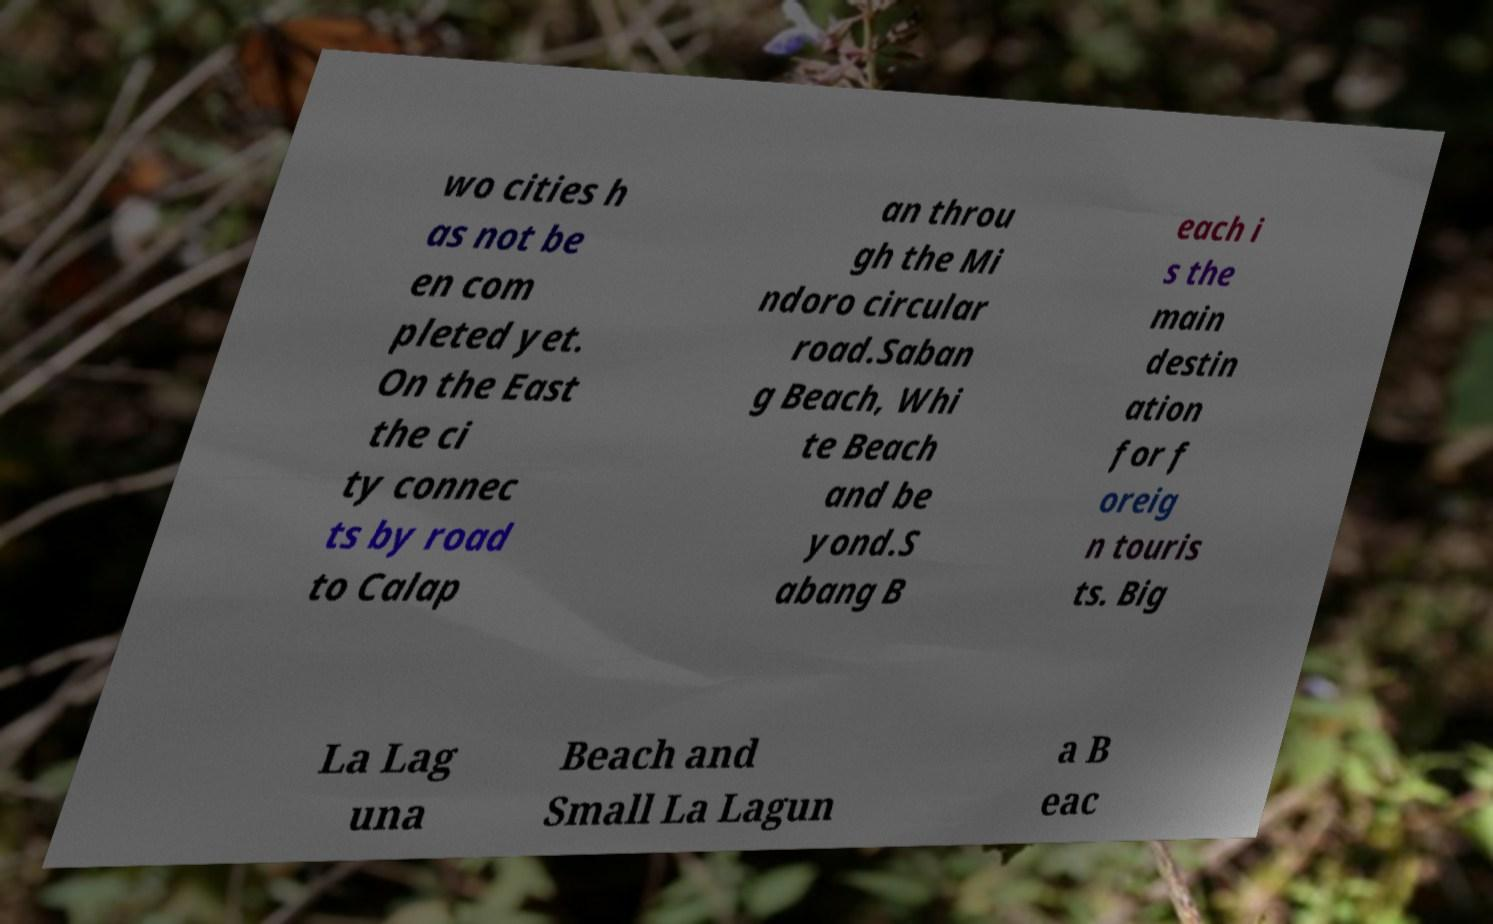Could you assist in decoding the text presented in this image and type it out clearly? wo cities h as not be en com pleted yet. On the East the ci ty connec ts by road to Calap an throu gh the Mi ndoro circular road.Saban g Beach, Whi te Beach and be yond.S abang B each i s the main destin ation for f oreig n touris ts. Big La Lag una Beach and Small La Lagun a B eac 